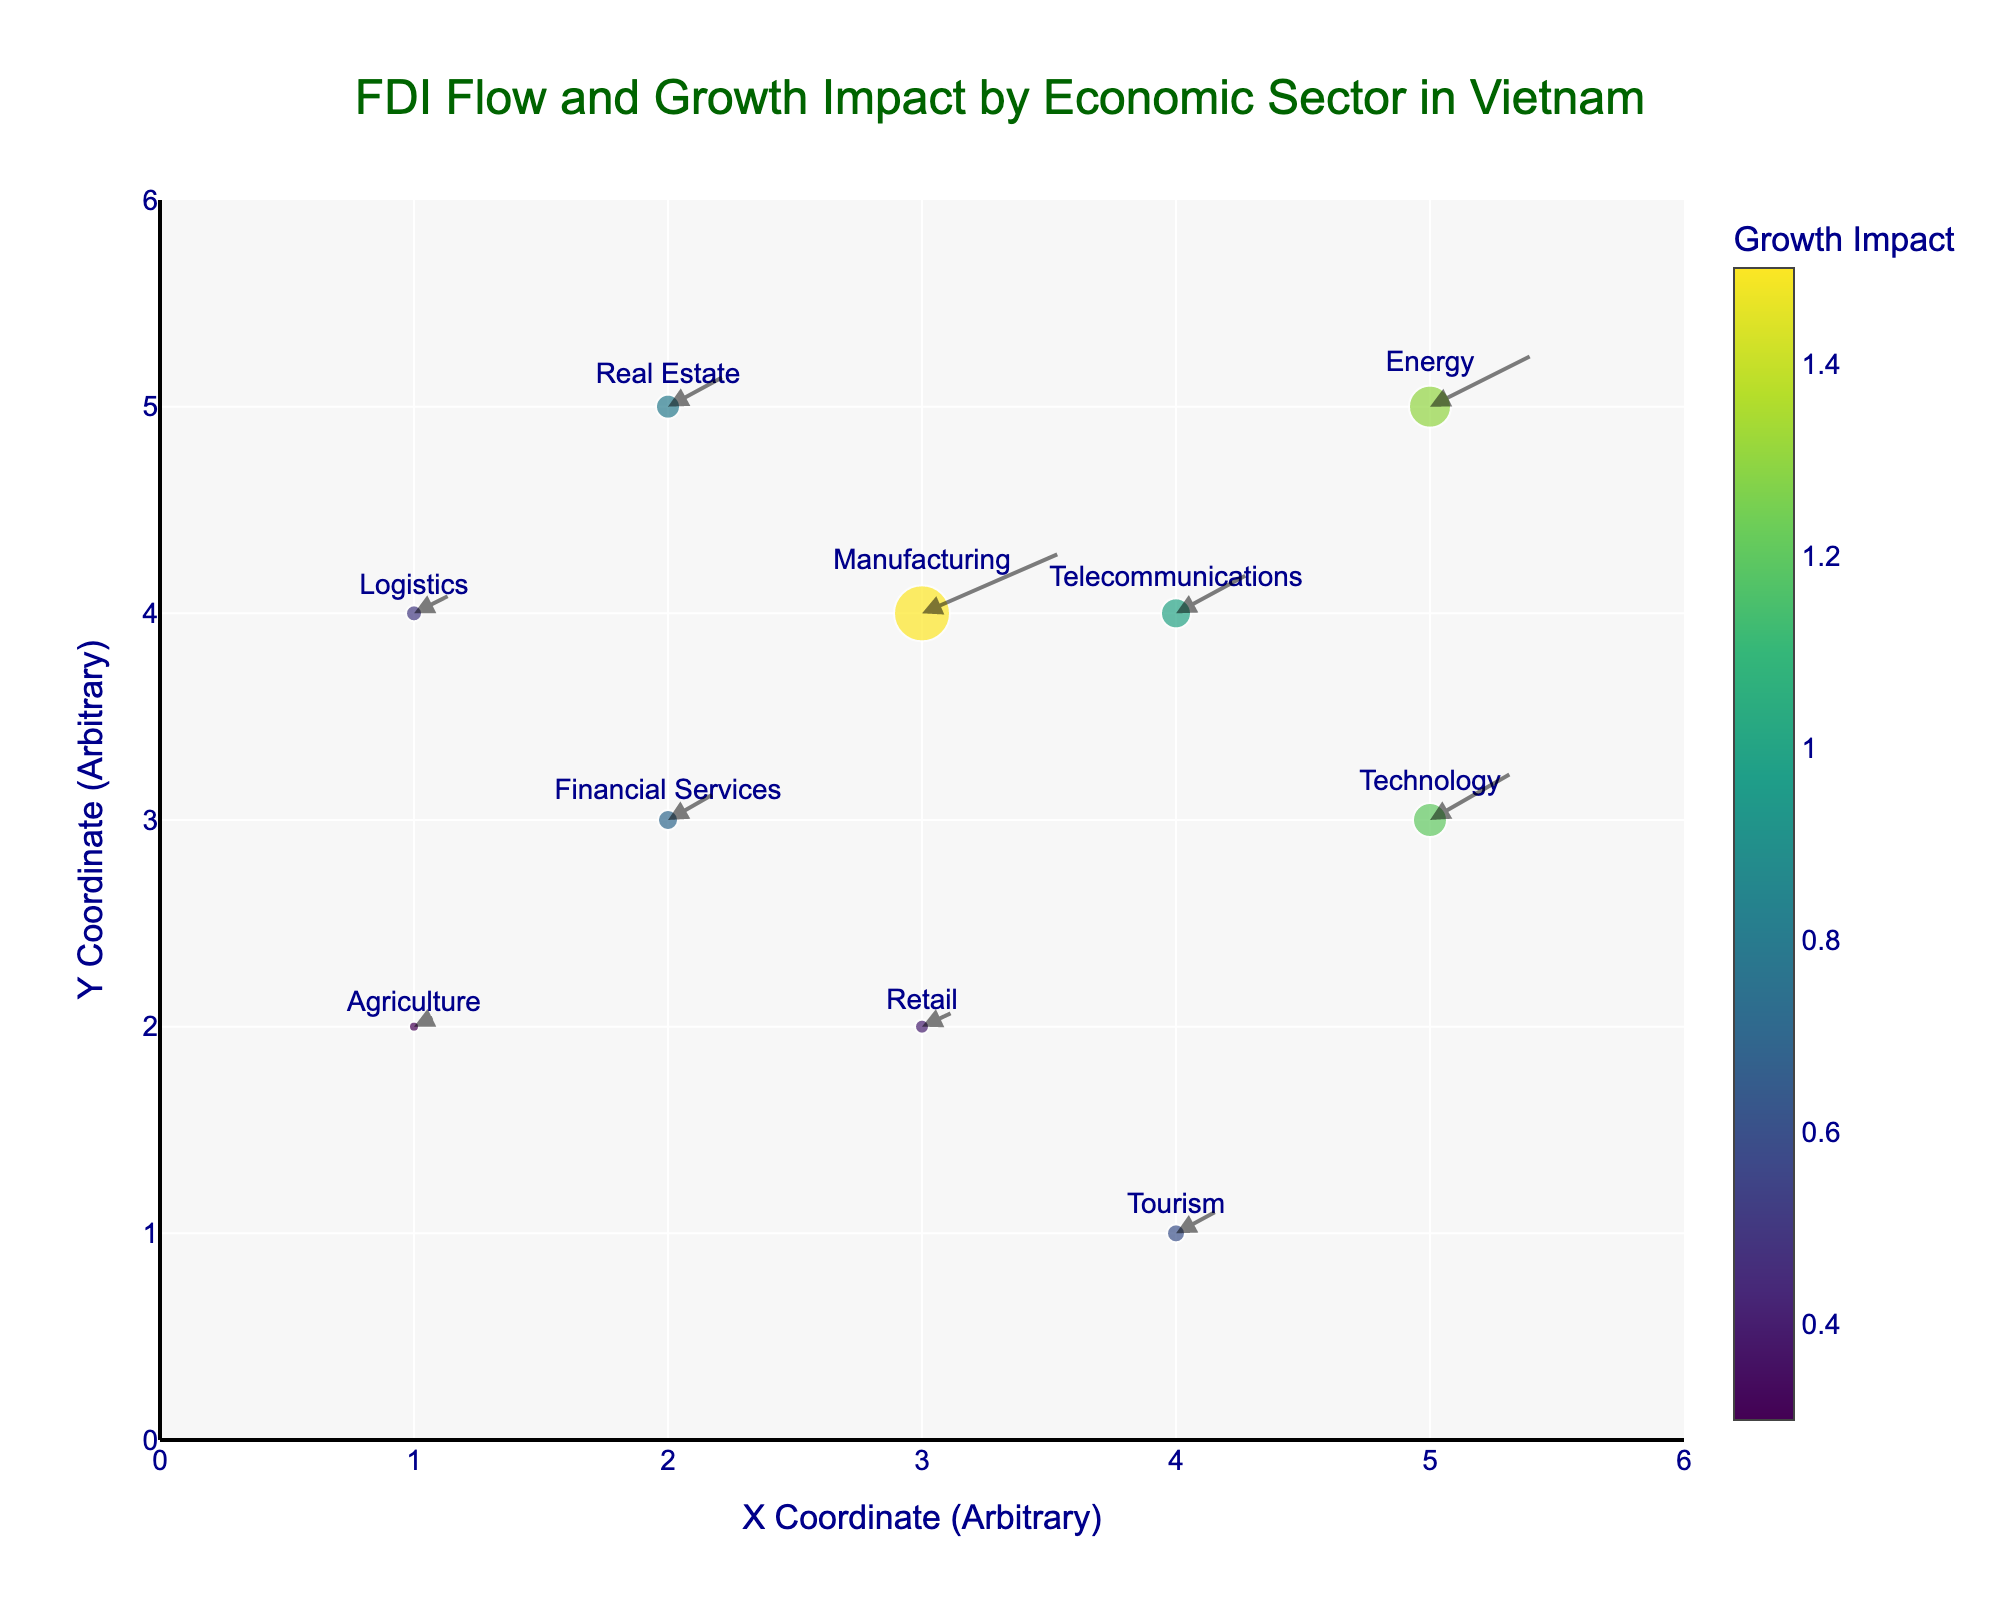what is the title of the plot? The title of the plot is written at the top center of the figure in large font size and dark green color.
Answer: FDI Flow and Growth Impact by Economic Sector in Vietnam how many sectors are represented in the plot? Count the number of distinct sectors labeled within the figure.
Answer: 10 which sector has the highest FDI flow? Observe the markers and their size. The largest marker represents the highest FDI flow.
Answer: Manufacturing which sector has the least growth impact? Check the annotation arrows and identify the one with the shortest length (smallest Growth Impact value).
Answer: Agriculture what is the average FDI flow across all sectors? Sum the FDI_Flow values for all sectors and divide by the number of sectors: (0.5 + 2.8 + 1.7 + 1.2 + 0.9 + 0.7 + 2.1 + 1.5 + 1.0 + 0.8) / 10 = 13.2 / 10 = 1.32
Answer: 1.32 what is the difference in Growth Impact between the Energy and Telecommunications sectors? Identify the Growth Impact of Energy (1.3) and Telecommunications (1.0), then subtract the latter from the former: 1.3 - 1.0 = 0.3
Answer: 0.3 which sector is located at (3,4)? Locate the point at the coordinates (3,4) and read the label of the corresponding sector.
Answer: Manufacturing which sectors are located in the same column (X-axis)? Find sectors with equal X values and list them. Real Estate and Financial Services are at (2, Y) and Tourism and Telecommunications at (4, Y).
Answer: Real Estate, Financial Services, Tourism, Telecommunications which sector experiences a better growth impact: Technology or Retail? Compare the Growth Impact values of Technology (1.2) with Retail (0.4). Technology has a higher value.
Answer: Technology how many sectors have an FDI flow greater than 1.5? Count the sectors whose FDI_Flow value is greater than 1.5 by examining the plot annotations or legend. Sectors with FDI_Flow >1.5 are Manufacturing, Technology, Energy, Telecommunications.
Answer: 4 